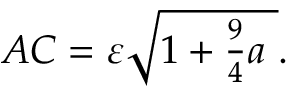Convert formula to latex. <formula><loc_0><loc_0><loc_500><loc_500>A C = \varepsilon { \sqrt { 1 + { \frac { 9 } { 4 } } a \ } } .</formula> 